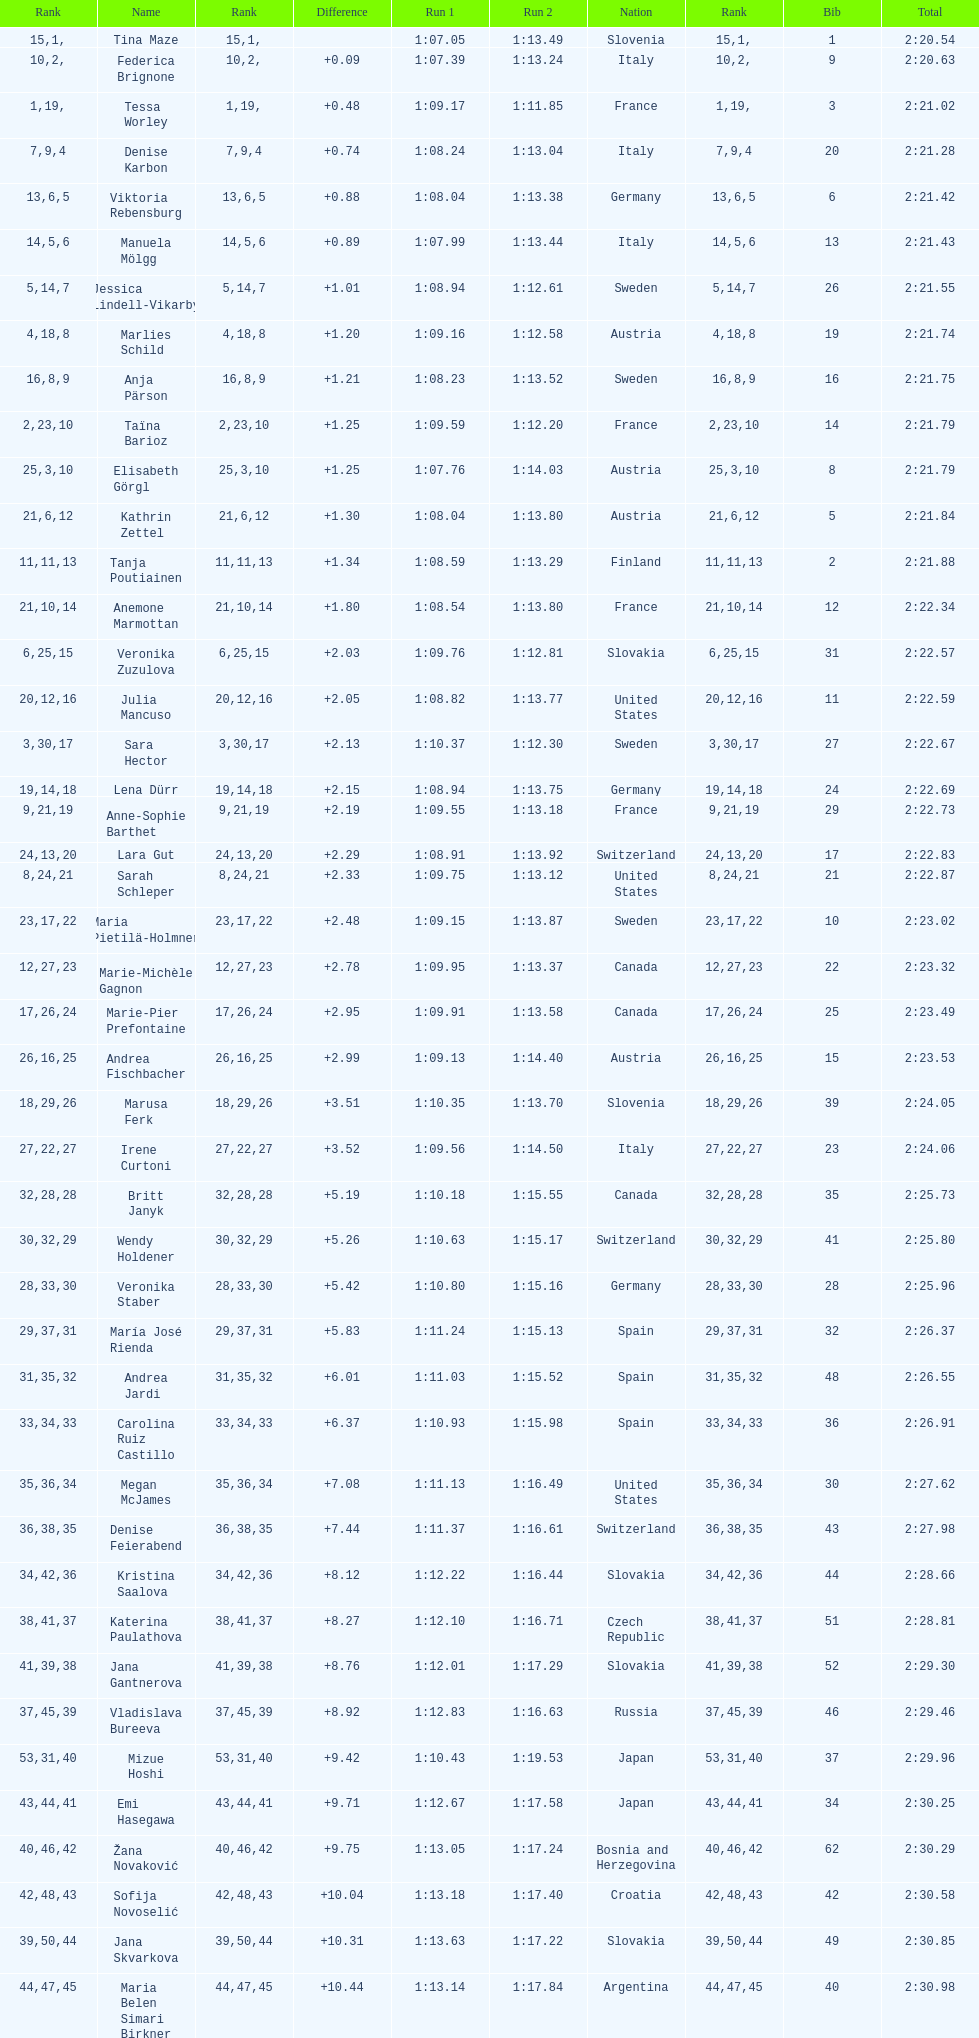Who was the last competitor to actually finish both runs? Martina Dubovska. 